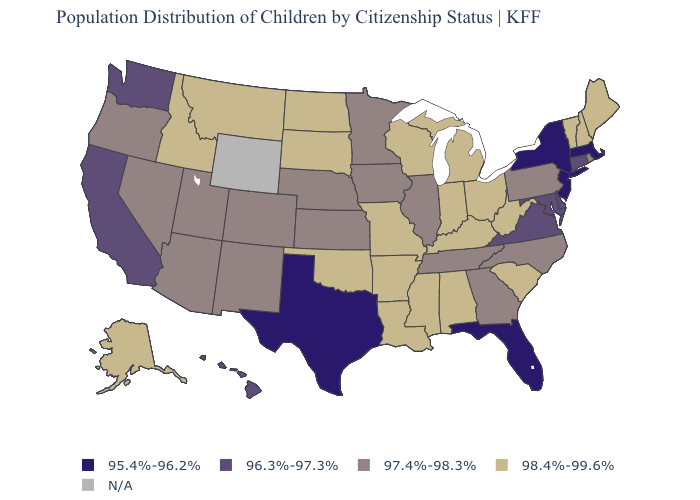What is the value of Arkansas?
Concise answer only. 98.4%-99.6%. What is the value of Washington?
Concise answer only. 96.3%-97.3%. Does Alaska have the highest value in the USA?
Answer briefly. Yes. What is the highest value in the MidWest ?
Answer briefly. 98.4%-99.6%. Does the map have missing data?
Be succinct. Yes. Among the states that border Indiana , which have the highest value?
Be succinct. Kentucky, Michigan, Ohio. Among the states that border Delaware , does Pennsylvania have the highest value?
Be succinct. Yes. Name the states that have a value in the range 95.4%-96.2%?
Write a very short answer. Florida, Massachusetts, New Jersey, New York, Texas. Name the states that have a value in the range N/A?
Write a very short answer. Wyoming. Name the states that have a value in the range 96.3%-97.3%?
Answer briefly. California, Connecticut, Delaware, Hawaii, Maryland, Virginia, Washington. Name the states that have a value in the range 96.3%-97.3%?
Concise answer only. California, Connecticut, Delaware, Hawaii, Maryland, Virginia, Washington. Among the states that border New Mexico , which have the lowest value?
Answer briefly. Texas. Name the states that have a value in the range N/A?
Keep it brief. Wyoming. Name the states that have a value in the range 96.3%-97.3%?
Keep it brief. California, Connecticut, Delaware, Hawaii, Maryland, Virginia, Washington. 